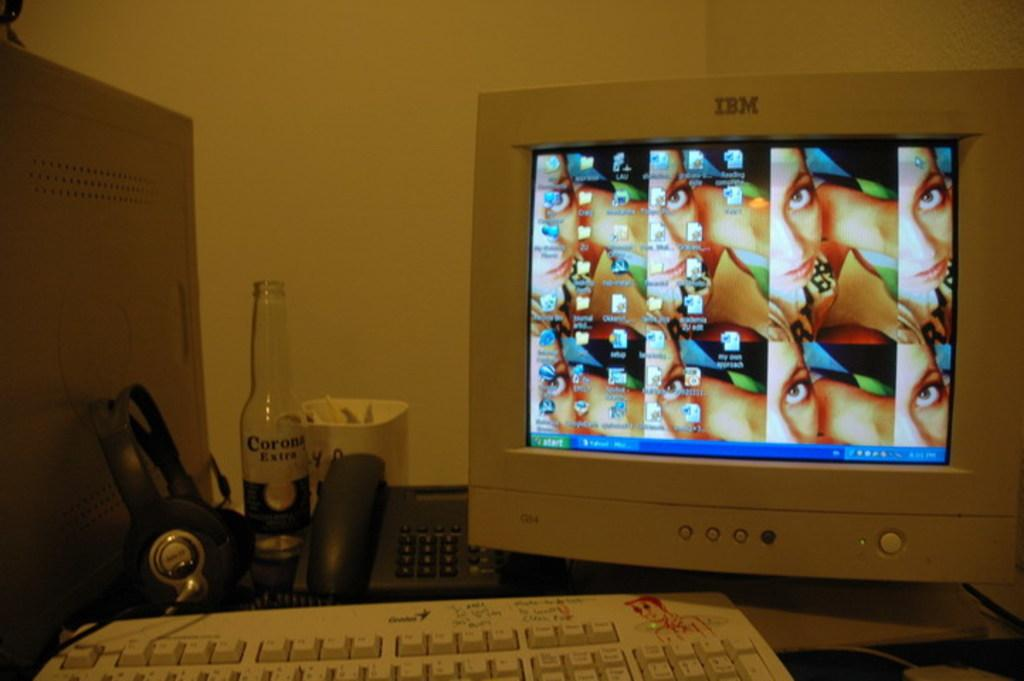<image>
Render a clear and concise summary of the photo. The green box on the screen says Start 